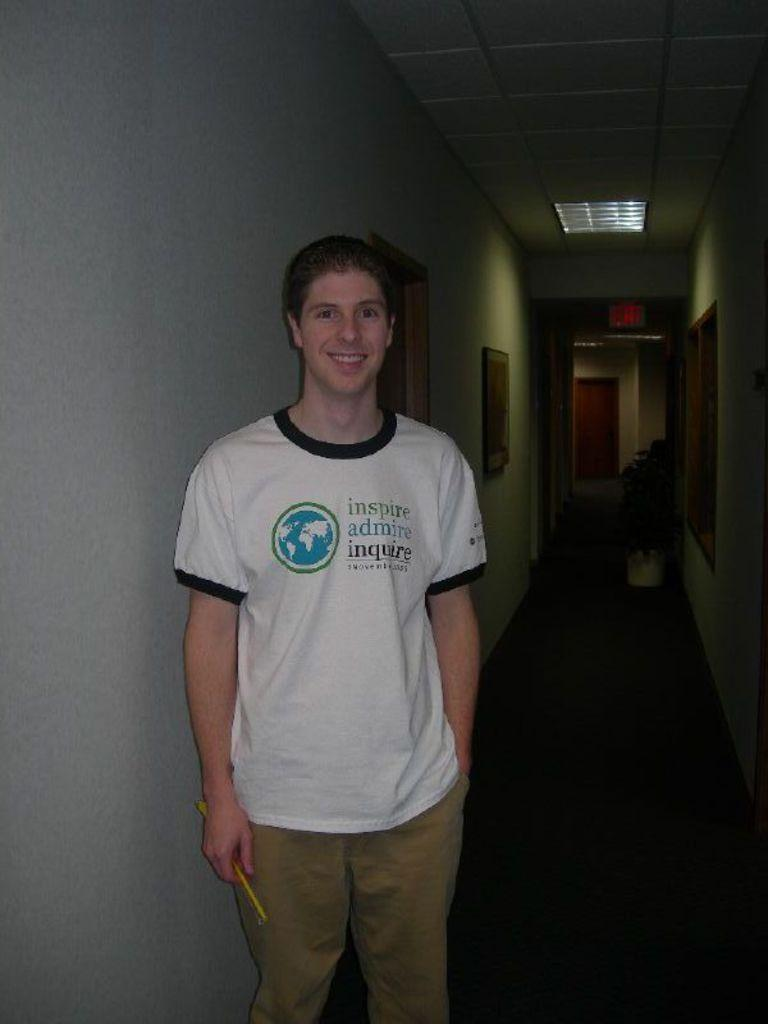What is the main subject of the image? There is a person standing in the image. Can you describe the person's clothing? The person is wearing a dress with white, black, and brown colors. What architectural features can be seen in the image? There are doors, windows, and a wall visible in the image. What is present near the wall? There is a flowerpot in the image. What type of lighting is visible in the image? There is a light visible in the image. What type of sign can be seen in the image? There is no sign present in the image. How does the person in the image appear to be sleeping? The person in the image is not sleeping; they are standing. 